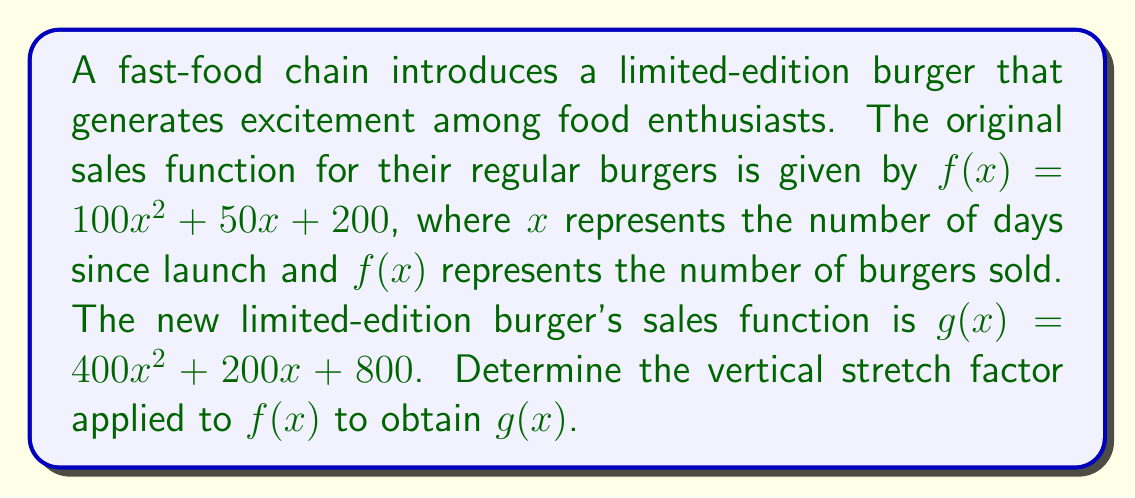Teach me how to tackle this problem. To find the vertical stretch factor, we need to compare the corresponding coefficients of $f(x)$ and $g(x)$:

1) First, let's write out the general form of a vertical stretch:
   $g(x) = a \cdot f(x)$, where $a$ is the stretch factor

2) Now, let's compare the coefficients:
   $f(x) = 100x^2 + 50x + 200$
   $g(x) = 400x^2 + 200x + 800$

3) We can see that each term in $g(x)$ is 4 times the corresponding term in $f(x)$:
   $400 = 4 \cdot 100$
   $200 = 4 \cdot 50$
   $800 = 4 \cdot 200$

4) This consistent multiplication by 4 across all terms indicates that:
   $g(x) = 4 \cdot f(x)$

5) Therefore, the vertical stretch factor is 4.

This means that for any given day, the sales of the limited-edition burger are 4 times higher than the sales of the regular burger would be on the same day.
Answer: 4 